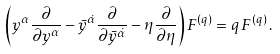Convert formula to latex. <formula><loc_0><loc_0><loc_500><loc_500>\left ( y ^ { \alpha } \frac { \partial } { \partial y ^ { \alpha } } - \bar { y } ^ { \dot { \alpha } } \frac { \partial } { \partial \bar { y } ^ { \dot { \alpha } } } - \eta \frac { \partial } { \partial \eta } \right ) F ^ { ( q ) } = q \, F ^ { ( q ) } \, .</formula> 